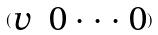<formula> <loc_0><loc_0><loc_500><loc_500>( \begin{matrix} v & 0 \cdot \cdot \cdot 0 \end{matrix} )</formula> 